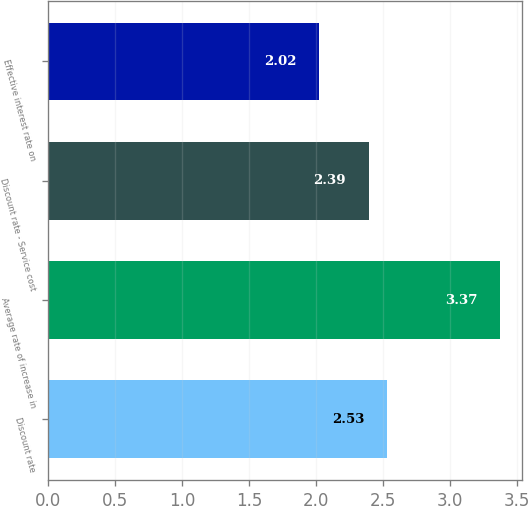<chart> <loc_0><loc_0><loc_500><loc_500><bar_chart><fcel>Discount rate<fcel>Average rate of increase in<fcel>Discount rate - Service cost<fcel>Effective interest rate on<nl><fcel>2.53<fcel>3.37<fcel>2.39<fcel>2.02<nl></chart> 